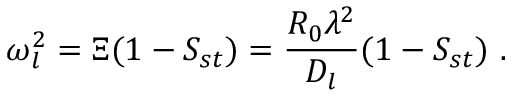<formula> <loc_0><loc_0><loc_500><loc_500>\omega _ { l } ^ { 2 } = \Xi ( 1 - S _ { s t } ) = \frac { R _ { 0 } \lambda ^ { 2 } } { D _ { l } } ( 1 - S _ { s t } ) \ .</formula> 